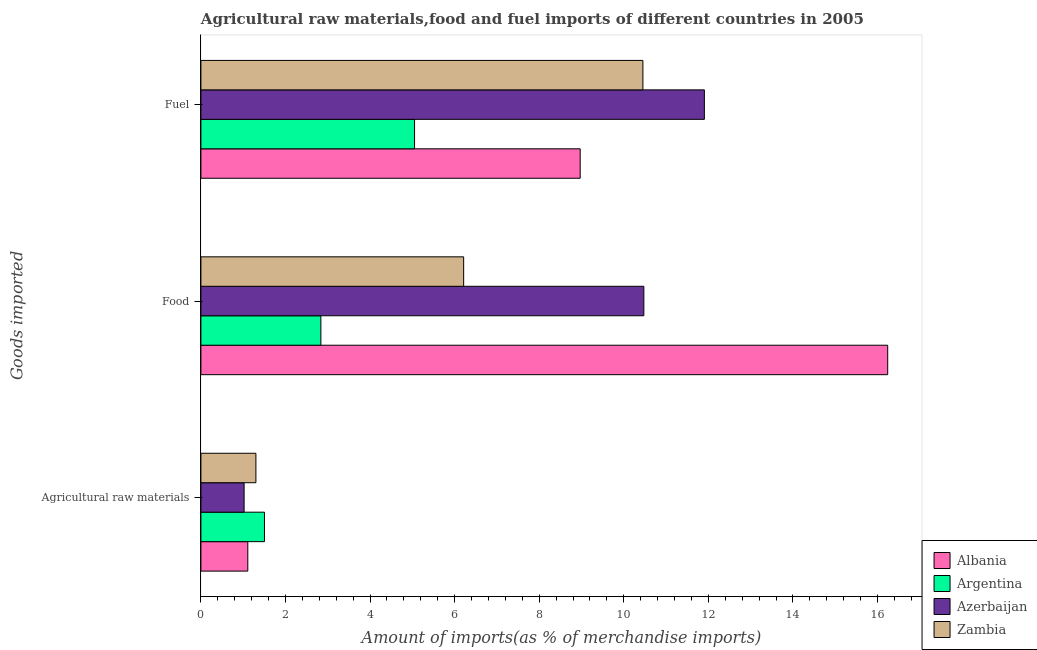How many different coloured bars are there?
Keep it short and to the point. 4. Are the number of bars per tick equal to the number of legend labels?
Your response must be concise. Yes. Are the number of bars on each tick of the Y-axis equal?
Your response must be concise. Yes. What is the label of the 1st group of bars from the top?
Keep it short and to the point. Fuel. What is the percentage of food imports in Zambia?
Provide a short and direct response. 6.21. Across all countries, what is the maximum percentage of fuel imports?
Offer a terse response. 11.91. Across all countries, what is the minimum percentage of raw materials imports?
Make the answer very short. 1.02. In which country was the percentage of food imports minimum?
Offer a very short reply. Argentina. What is the total percentage of food imports in the graph?
Your answer should be compact. 35.77. What is the difference between the percentage of food imports in Azerbaijan and that in Albania?
Ensure brevity in your answer.  -5.77. What is the difference between the percentage of raw materials imports in Albania and the percentage of fuel imports in Argentina?
Offer a very short reply. -3.94. What is the average percentage of fuel imports per country?
Offer a terse response. 9.09. What is the difference between the percentage of fuel imports and percentage of raw materials imports in Argentina?
Offer a terse response. 3.55. What is the ratio of the percentage of raw materials imports in Zambia to that in Argentina?
Keep it short and to the point. 0.87. Is the percentage of food imports in Azerbaijan less than that in Argentina?
Make the answer very short. No. What is the difference between the highest and the second highest percentage of raw materials imports?
Give a very brief answer. 0.2. What is the difference between the highest and the lowest percentage of fuel imports?
Provide a succinct answer. 6.85. Is the sum of the percentage of fuel imports in Azerbaijan and Argentina greater than the maximum percentage of raw materials imports across all countries?
Make the answer very short. Yes. What does the 1st bar from the top in Agricultural raw materials represents?
Provide a short and direct response. Zambia. What does the 3rd bar from the bottom in Agricultural raw materials represents?
Ensure brevity in your answer.  Azerbaijan. Is it the case that in every country, the sum of the percentage of raw materials imports and percentage of food imports is greater than the percentage of fuel imports?
Your answer should be compact. No. Where does the legend appear in the graph?
Give a very brief answer. Bottom right. How many legend labels are there?
Offer a terse response. 4. How are the legend labels stacked?
Your response must be concise. Vertical. What is the title of the graph?
Offer a terse response. Agricultural raw materials,food and fuel imports of different countries in 2005. Does "Isle of Man" appear as one of the legend labels in the graph?
Offer a terse response. No. What is the label or title of the X-axis?
Your answer should be very brief. Amount of imports(as % of merchandise imports). What is the label or title of the Y-axis?
Your answer should be very brief. Goods imported. What is the Amount of imports(as % of merchandise imports) in Albania in Agricultural raw materials?
Offer a terse response. 1.11. What is the Amount of imports(as % of merchandise imports) of Argentina in Agricultural raw materials?
Offer a terse response. 1.5. What is the Amount of imports(as % of merchandise imports) in Azerbaijan in Agricultural raw materials?
Provide a short and direct response. 1.02. What is the Amount of imports(as % of merchandise imports) in Zambia in Agricultural raw materials?
Your answer should be very brief. 1.3. What is the Amount of imports(as % of merchandise imports) of Albania in Food?
Keep it short and to the point. 16.24. What is the Amount of imports(as % of merchandise imports) in Argentina in Food?
Provide a short and direct response. 2.84. What is the Amount of imports(as % of merchandise imports) of Azerbaijan in Food?
Ensure brevity in your answer.  10.47. What is the Amount of imports(as % of merchandise imports) in Zambia in Food?
Offer a terse response. 6.21. What is the Amount of imports(as % of merchandise imports) of Albania in Fuel?
Ensure brevity in your answer.  8.97. What is the Amount of imports(as % of merchandise imports) of Argentina in Fuel?
Provide a short and direct response. 5.05. What is the Amount of imports(as % of merchandise imports) in Azerbaijan in Fuel?
Ensure brevity in your answer.  11.91. What is the Amount of imports(as % of merchandise imports) in Zambia in Fuel?
Ensure brevity in your answer.  10.45. Across all Goods imported, what is the maximum Amount of imports(as % of merchandise imports) in Albania?
Your answer should be very brief. 16.24. Across all Goods imported, what is the maximum Amount of imports(as % of merchandise imports) in Argentina?
Offer a terse response. 5.05. Across all Goods imported, what is the maximum Amount of imports(as % of merchandise imports) in Azerbaijan?
Ensure brevity in your answer.  11.91. Across all Goods imported, what is the maximum Amount of imports(as % of merchandise imports) of Zambia?
Your response must be concise. 10.45. Across all Goods imported, what is the minimum Amount of imports(as % of merchandise imports) in Albania?
Your answer should be very brief. 1.11. Across all Goods imported, what is the minimum Amount of imports(as % of merchandise imports) of Argentina?
Offer a very short reply. 1.5. Across all Goods imported, what is the minimum Amount of imports(as % of merchandise imports) of Azerbaijan?
Your answer should be very brief. 1.02. Across all Goods imported, what is the minimum Amount of imports(as % of merchandise imports) in Zambia?
Offer a terse response. 1.3. What is the total Amount of imports(as % of merchandise imports) of Albania in the graph?
Provide a short and direct response. 26.32. What is the total Amount of imports(as % of merchandise imports) in Argentina in the graph?
Provide a short and direct response. 9.39. What is the total Amount of imports(as % of merchandise imports) of Azerbaijan in the graph?
Your response must be concise. 23.4. What is the total Amount of imports(as % of merchandise imports) in Zambia in the graph?
Make the answer very short. 17.97. What is the difference between the Amount of imports(as % of merchandise imports) of Albania in Agricultural raw materials and that in Food?
Provide a short and direct response. -15.13. What is the difference between the Amount of imports(as % of merchandise imports) of Argentina in Agricultural raw materials and that in Food?
Your answer should be very brief. -1.33. What is the difference between the Amount of imports(as % of merchandise imports) of Azerbaijan in Agricultural raw materials and that in Food?
Keep it short and to the point. -9.45. What is the difference between the Amount of imports(as % of merchandise imports) in Zambia in Agricultural raw materials and that in Food?
Make the answer very short. -4.91. What is the difference between the Amount of imports(as % of merchandise imports) of Albania in Agricultural raw materials and that in Fuel?
Your answer should be compact. -7.86. What is the difference between the Amount of imports(as % of merchandise imports) in Argentina in Agricultural raw materials and that in Fuel?
Give a very brief answer. -3.55. What is the difference between the Amount of imports(as % of merchandise imports) of Azerbaijan in Agricultural raw materials and that in Fuel?
Offer a very short reply. -10.88. What is the difference between the Amount of imports(as % of merchandise imports) in Zambia in Agricultural raw materials and that in Fuel?
Your response must be concise. -9.15. What is the difference between the Amount of imports(as % of merchandise imports) in Albania in Food and that in Fuel?
Offer a terse response. 7.27. What is the difference between the Amount of imports(as % of merchandise imports) in Argentina in Food and that in Fuel?
Your answer should be very brief. -2.21. What is the difference between the Amount of imports(as % of merchandise imports) of Azerbaijan in Food and that in Fuel?
Keep it short and to the point. -1.43. What is the difference between the Amount of imports(as % of merchandise imports) in Zambia in Food and that in Fuel?
Your response must be concise. -4.24. What is the difference between the Amount of imports(as % of merchandise imports) of Albania in Agricultural raw materials and the Amount of imports(as % of merchandise imports) of Argentina in Food?
Your response must be concise. -1.73. What is the difference between the Amount of imports(as % of merchandise imports) in Albania in Agricultural raw materials and the Amount of imports(as % of merchandise imports) in Azerbaijan in Food?
Give a very brief answer. -9.37. What is the difference between the Amount of imports(as % of merchandise imports) in Albania in Agricultural raw materials and the Amount of imports(as % of merchandise imports) in Zambia in Food?
Offer a very short reply. -5.1. What is the difference between the Amount of imports(as % of merchandise imports) of Argentina in Agricultural raw materials and the Amount of imports(as % of merchandise imports) of Azerbaijan in Food?
Your answer should be very brief. -8.97. What is the difference between the Amount of imports(as % of merchandise imports) in Argentina in Agricultural raw materials and the Amount of imports(as % of merchandise imports) in Zambia in Food?
Provide a short and direct response. -4.71. What is the difference between the Amount of imports(as % of merchandise imports) of Azerbaijan in Agricultural raw materials and the Amount of imports(as % of merchandise imports) of Zambia in Food?
Give a very brief answer. -5.19. What is the difference between the Amount of imports(as % of merchandise imports) in Albania in Agricultural raw materials and the Amount of imports(as % of merchandise imports) in Argentina in Fuel?
Provide a succinct answer. -3.94. What is the difference between the Amount of imports(as % of merchandise imports) in Albania in Agricultural raw materials and the Amount of imports(as % of merchandise imports) in Azerbaijan in Fuel?
Your answer should be compact. -10.8. What is the difference between the Amount of imports(as % of merchandise imports) of Albania in Agricultural raw materials and the Amount of imports(as % of merchandise imports) of Zambia in Fuel?
Your answer should be very brief. -9.34. What is the difference between the Amount of imports(as % of merchandise imports) of Argentina in Agricultural raw materials and the Amount of imports(as % of merchandise imports) of Azerbaijan in Fuel?
Your answer should be compact. -10.4. What is the difference between the Amount of imports(as % of merchandise imports) in Argentina in Agricultural raw materials and the Amount of imports(as % of merchandise imports) in Zambia in Fuel?
Your response must be concise. -8.95. What is the difference between the Amount of imports(as % of merchandise imports) in Azerbaijan in Agricultural raw materials and the Amount of imports(as % of merchandise imports) in Zambia in Fuel?
Provide a short and direct response. -9.43. What is the difference between the Amount of imports(as % of merchandise imports) of Albania in Food and the Amount of imports(as % of merchandise imports) of Argentina in Fuel?
Your answer should be compact. 11.19. What is the difference between the Amount of imports(as % of merchandise imports) in Albania in Food and the Amount of imports(as % of merchandise imports) in Azerbaijan in Fuel?
Give a very brief answer. 4.34. What is the difference between the Amount of imports(as % of merchandise imports) in Albania in Food and the Amount of imports(as % of merchandise imports) in Zambia in Fuel?
Your response must be concise. 5.79. What is the difference between the Amount of imports(as % of merchandise imports) of Argentina in Food and the Amount of imports(as % of merchandise imports) of Azerbaijan in Fuel?
Provide a short and direct response. -9.07. What is the difference between the Amount of imports(as % of merchandise imports) of Argentina in Food and the Amount of imports(as % of merchandise imports) of Zambia in Fuel?
Give a very brief answer. -7.62. What is the difference between the Amount of imports(as % of merchandise imports) of Azerbaijan in Food and the Amount of imports(as % of merchandise imports) of Zambia in Fuel?
Provide a short and direct response. 0.02. What is the average Amount of imports(as % of merchandise imports) of Albania per Goods imported?
Your response must be concise. 8.77. What is the average Amount of imports(as % of merchandise imports) of Argentina per Goods imported?
Your answer should be compact. 3.13. What is the average Amount of imports(as % of merchandise imports) of Azerbaijan per Goods imported?
Ensure brevity in your answer.  7.8. What is the average Amount of imports(as % of merchandise imports) in Zambia per Goods imported?
Offer a very short reply. 5.99. What is the difference between the Amount of imports(as % of merchandise imports) in Albania and Amount of imports(as % of merchandise imports) in Argentina in Agricultural raw materials?
Ensure brevity in your answer.  -0.39. What is the difference between the Amount of imports(as % of merchandise imports) in Albania and Amount of imports(as % of merchandise imports) in Azerbaijan in Agricultural raw materials?
Your answer should be very brief. 0.09. What is the difference between the Amount of imports(as % of merchandise imports) of Albania and Amount of imports(as % of merchandise imports) of Zambia in Agricultural raw materials?
Ensure brevity in your answer.  -0.19. What is the difference between the Amount of imports(as % of merchandise imports) in Argentina and Amount of imports(as % of merchandise imports) in Azerbaijan in Agricultural raw materials?
Make the answer very short. 0.48. What is the difference between the Amount of imports(as % of merchandise imports) in Argentina and Amount of imports(as % of merchandise imports) in Zambia in Agricultural raw materials?
Your answer should be compact. 0.2. What is the difference between the Amount of imports(as % of merchandise imports) in Azerbaijan and Amount of imports(as % of merchandise imports) in Zambia in Agricultural raw materials?
Your response must be concise. -0.28. What is the difference between the Amount of imports(as % of merchandise imports) in Albania and Amount of imports(as % of merchandise imports) in Argentina in Food?
Provide a succinct answer. 13.4. What is the difference between the Amount of imports(as % of merchandise imports) of Albania and Amount of imports(as % of merchandise imports) of Azerbaijan in Food?
Provide a short and direct response. 5.77. What is the difference between the Amount of imports(as % of merchandise imports) in Albania and Amount of imports(as % of merchandise imports) in Zambia in Food?
Provide a short and direct response. 10.03. What is the difference between the Amount of imports(as % of merchandise imports) in Argentina and Amount of imports(as % of merchandise imports) in Azerbaijan in Food?
Your answer should be compact. -7.64. What is the difference between the Amount of imports(as % of merchandise imports) of Argentina and Amount of imports(as % of merchandise imports) of Zambia in Food?
Make the answer very short. -3.38. What is the difference between the Amount of imports(as % of merchandise imports) of Azerbaijan and Amount of imports(as % of merchandise imports) of Zambia in Food?
Your response must be concise. 4.26. What is the difference between the Amount of imports(as % of merchandise imports) in Albania and Amount of imports(as % of merchandise imports) in Argentina in Fuel?
Your answer should be very brief. 3.92. What is the difference between the Amount of imports(as % of merchandise imports) in Albania and Amount of imports(as % of merchandise imports) in Azerbaijan in Fuel?
Your answer should be very brief. -2.94. What is the difference between the Amount of imports(as % of merchandise imports) in Albania and Amount of imports(as % of merchandise imports) in Zambia in Fuel?
Provide a short and direct response. -1.48. What is the difference between the Amount of imports(as % of merchandise imports) in Argentina and Amount of imports(as % of merchandise imports) in Azerbaijan in Fuel?
Give a very brief answer. -6.85. What is the difference between the Amount of imports(as % of merchandise imports) in Argentina and Amount of imports(as % of merchandise imports) in Zambia in Fuel?
Make the answer very short. -5.4. What is the difference between the Amount of imports(as % of merchandise imports) in Azerbaijan and Amount of imports(as % of merchandise imports) in Zambia in Fuel?
Provide a succinct answer. 1.45. What is the ratio of the Amount of imports(as % of merchandise imports) of Albania in Agricultural raw materials to that in Food?
Offer a very short reply. 0.07. What is the ratio of the Amount of imports(as % of merchandise imports) of Argentina in Agricultural raw materials to that in Food?
Your response must be concise. 0.53. What is the ratio of the Amount of imports(as % of merchandise imports) in Azerbaijan in Agricultural raw materials to that in Food?
Provide a short and direct response. 0.1. What is the ratio of the Amount of imports(as % of merchandise imports) of Zambia in Agricultural raw materials to that in Food?
Provide a short and direct response. 0.21. What is the ratio of the Amount of imports(as % of merchandise imports) of Albania in Agricultural raw materials to that in Fuel?
Give a very brief answer. 0.12. What is the ratio of the Amount of imports(as % of merchandise imports) in Argentina in Agricultural raw materials to that in Fuel?
Your answer should be compact. 0.3. What is the ratio of the Amount of imports(as % of merchandise imports) of Azerbaijan in Agricultural raw materials to that in Fuel?
Make the answer very short. 0.09. What is the ratio of the Amount of imports(as % of merchandise imports) in Zambia in Agricultural raw materials to that in Fuel?
Ensure brevity in your answer.  0.12. What is the ratio of the Amount of imports(as % of merchandise imports) in Albania in Food to that in Fuel?
Your response must be concise. 1.81. What is the ratio of the Amount of imports(as % of merchandise imports) of Argentina in Food to that in Fuel?
Offer a terse response. 0.56. What is the ratio of the Amount of imports(as % of merchandise imports) in Azerbaijan in Food to that in Fuel?
Your answer should be compact. 0.88. What is the ratio of the Amount of imports(as % of merchandise imports) in Zambia in Food to that in Fuel?
Keep it short and to the point. 0.59. What is the difference between the highest and the second highest Amount of imports(as % of merchandise imports) in Albania?
Make the answer very short. 7.27. What is the difference between the highest and the second highest Amount of imports(as % of merchandise imports) in Argentina?
Offer a terse response. 2.21. What is the difference between the highest and the second highest Amount of imports(as % of merchandise imports) of Azerbaijan?
Give a very brief answer. 1.43. What is the difference between the highest and the second highest Amount of imports(as % of merchandise imports) of Zambia?
Ensure brevity in your answer.  4.24. What is the difference between the highest and the lowest Amount of imports(as % of merchandise imports) in Albania?
Offer a very short reply. 15.13. What is the difference between the highest and the lowest Amount of imports(as % of merchandise imports) of Argentina?
Your response must be concise. 3.55. What is the difference between the highest and the lowest Amount of imports(as % of merchandise imports) in Azerbaijan?
Offer a very short reply. 10.88. What is the difference between the highest and the lowest Amount of imports(as % of merchandise imports) in Zambia?
Provide a succinct answer. 9.15. 